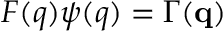<formula> <loc_0><loc_0><loc_500><loc_500>F ( q ) \psi ( q ) = \Gamma ( { q } )</formula> 